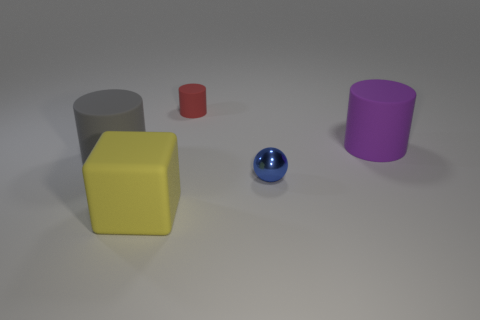Subtract all small red cylinders. How many cylinders are left? 2 Add 3 small red matte cylinders. How many objects exist? 8 Subtract all cylinders. How many objects are left? 2 Subtract all brown balls. How many gray cylinders are left? 1 Subtract all rubber cylinders. Subtract all red matte cylinders. How many objects are left? 1 Add 5 tiny rubber objects. How many tiny rubber objects are left? 6 Add 3 blue balls. How many blue balls exist? 4 Subtract all red cylinders. How many cylinders are left? 2 Subtract 0 cyan spheres. How many objects are left? 5 Subtract 1 spheres. How many spheres are left? 0 